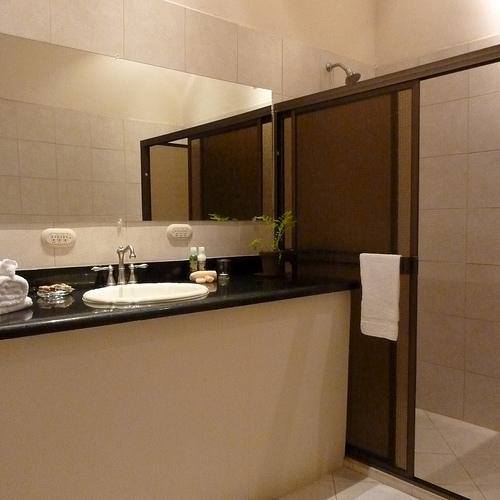Can you take a bath in this little bathtub?
Write a very short answer. No. Are there more than three towels visible in the photo?
Give a very brief answer. No. What kind of room is shown?
Be succinct. Bathroom. What color is the sink?
Be succinct. White. 